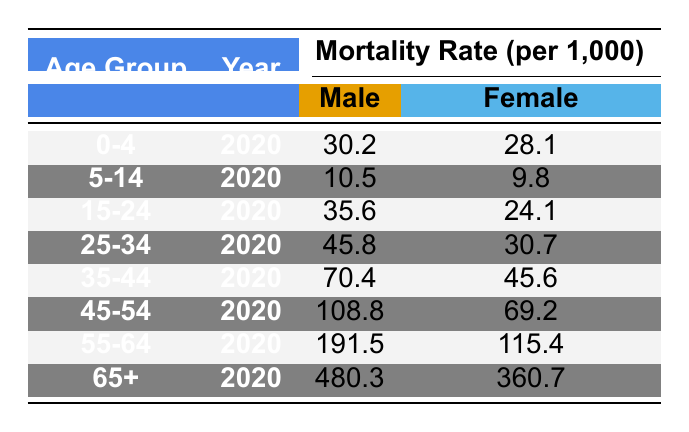What is the male mortality rate for the 45-54 age group in 2020? The table shows that the male mortality rate for the 45-54 age group in 2020 is listed under that row. The value is 108.8.
Answer: 108.8 What is the female mortality rate for the 15-24 age group? The table indicates the female mortality rate for the 15-24 age group in the corresponding row, which is 24.1.
Answer: 24.1 Is the mortality rate for males higher than for females in the 25-34 age group? Looking at the respective rates for the 25-34 age group, males have a rate of 45.8 while females have 30.7. Since 45.8 is greater than 30.7, the statement is true.
Answer: Yes What is the difference between the male and female mortality rates in the 65+ age group? In the 65+ age group, the male mortality rate is 480.3 and the female mortality rate is 360.7. The difference can be calculated as 480.3 - 360.7 = 119.6.
Answer: 119.6 What age group has the highest female mortality rate? By scanning the female mortality rates listed in the table, the 65+ age group has the highest rate of 360.7, which is greater than all other listed age groups.
Answer: 65+ What is the average mortality rate for females across all age groups in 2020? To find the average female mortality rate, sum the female rates (28.1 + 9.8 + 24.1 + 30.7 + 45.6 + 69.2 + 115.4 + 360.7 = 682.6) and then divide by the number of age groups (8). Thus, the average is 682.6 / 8 = 85.325.
Answer: 85.3 Is the mortality rate for the 0-4 age group lower than the 5-14 age group for both genders? For males, the rates are 30.2 (0-4) and 10.5 (5-14), showing that 30.2 is not lower than 10.5; thus, the claim is false. For females, the rates are 28.1 (0-4) and 9.8 (5-14), and 28.1 is also not lower than 9.8; hence, the statement is false for both genders as well.
Answer: No Which age group shows an increase in male mortality rate over the female mortality rate? The male mortality rates are significantly higher than female rates for all age groups, especially prominent in 35-44 (70.4 vs. 45.6), 45-54 (108.8 vs. 69.2), 55-64 (191.5 vs. 115.4), and 65+ (480.3 vs. 360.7). Every age group confirms that the male mortality rate is higher.
Answer: All age groups 